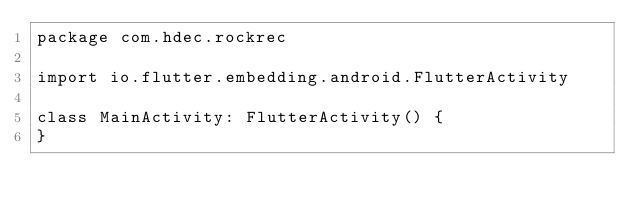<code> <loc_0><loc_0><loc_500><loc_500><_Kotlin_>package com.hdec.rockrec

import io.flutter.embedding.android.FlutterActivity

class MainActivity: FlutterActivity() {
}
</code> 